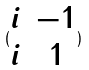Convert formula to latex. <formula><loc_0><loc_0><loc_500><loc_500>( \begin{matrix} i & - 1 \\ i & 1 \end{matrix} )</formula> 